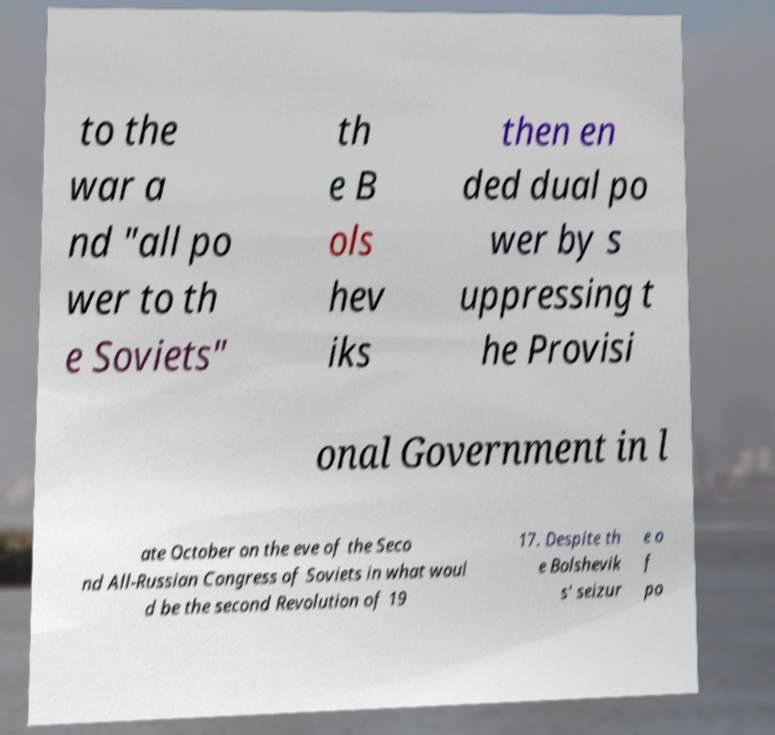Please identify and transcribe the text found in this image. to the war a nd "all po wer to th e Soviets" th e B ols hev iks then en ded dual po wer by s uppressing t he Provisi onal Government in l ate October on the eve of the Seco nd All-Russian Congress of Soviets in what woul d be the second Revolution of 19 17. Despite th e Bolshevik s' seizur e o f po 